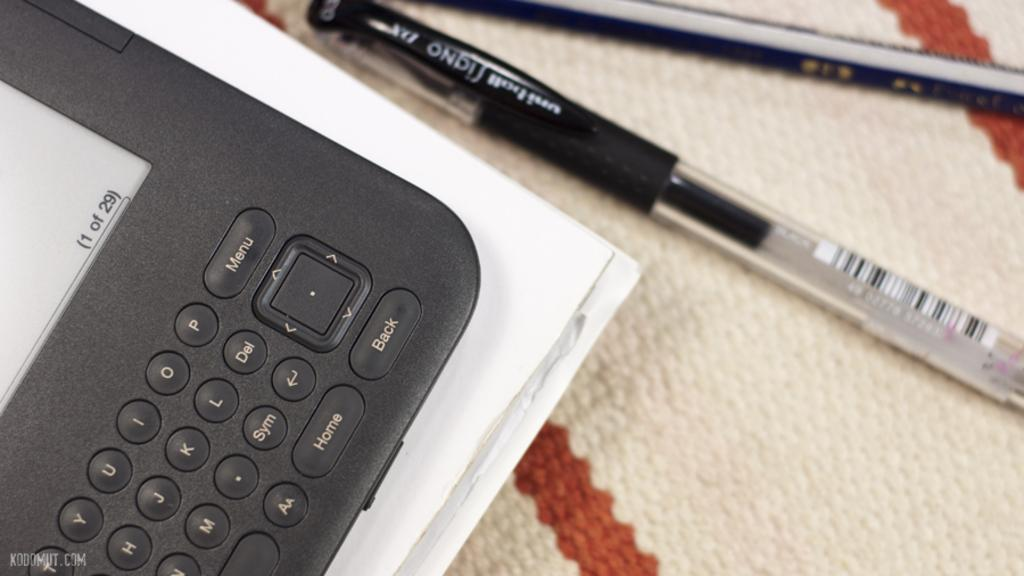<image>
Write a terse but informative summary of the picture. Pen next to a device that is on page 1 of 29. 